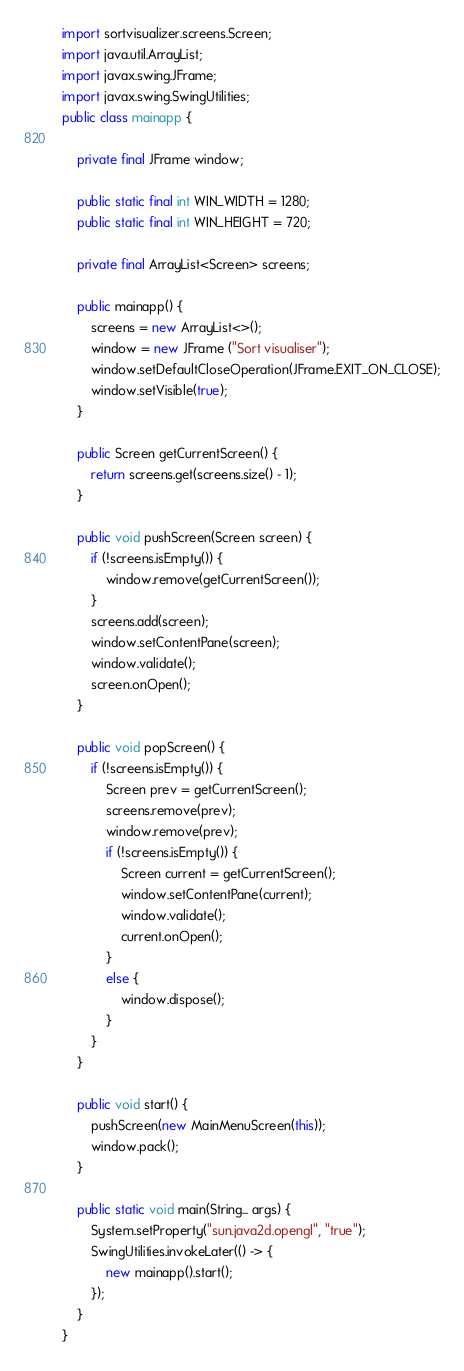<code> <loc_0><loc_0><loc_500><loc_500><_Java_>import sortvisualizer.screens.Screen;
import java.util.ArrayList;
import javax.swing.JFrame;
import javax.swing.SwingUtilities;
public class mainapp {

    private final JFrame window;

    public static final int WIN_WIDTH = 1280;
    public static final int WIN_HEIGHT = 720;

    private final ArrayList<Screen> screens;

    public mainapp() {
        screens = new ArrayList<>();
        window = new JFrame ("Sort visualiser");
        window.setDefaultCloseOperation(JFrame.EXIT_ON_CLOSE);
        window.setVisible(true);
    }

    public Screen getCurrentScreen() {
        return screens.get(screens.size() - 1);
    }

    public void pushScreen(Screen screen) {
        if (!screens.isEmpty()) {
            window.remove(getCurrentScreen());
        }
        screens.add(screen);
        window.setContentPane(screen);
        window.validate();
        screen.onOpen();
    }

    public void popScreen() {
        if (!screens.isEmpty()) {
            Screen prev = getCurrentScreen();
            screens.remove(prev);
            window.remove(prev);
            if (!screens.isEmpty()) {
                Screen current = getCurrentScreen();
                window.setContentPane(current);
                window.validate();
                current.onOpen();
            }
            else {
                window.dispose();
            }
        }
    }

    public void start() {
        pushScreen(new MainMenuScreen(this));
        window.pack();
    }

    public static void main(String... args) {
        System.setProperty("sun.java2d.opengl", "true");
        SwingUtilities.invokeLater(() -> {
            new mainapp().start();
        });
    }
}
</code> 